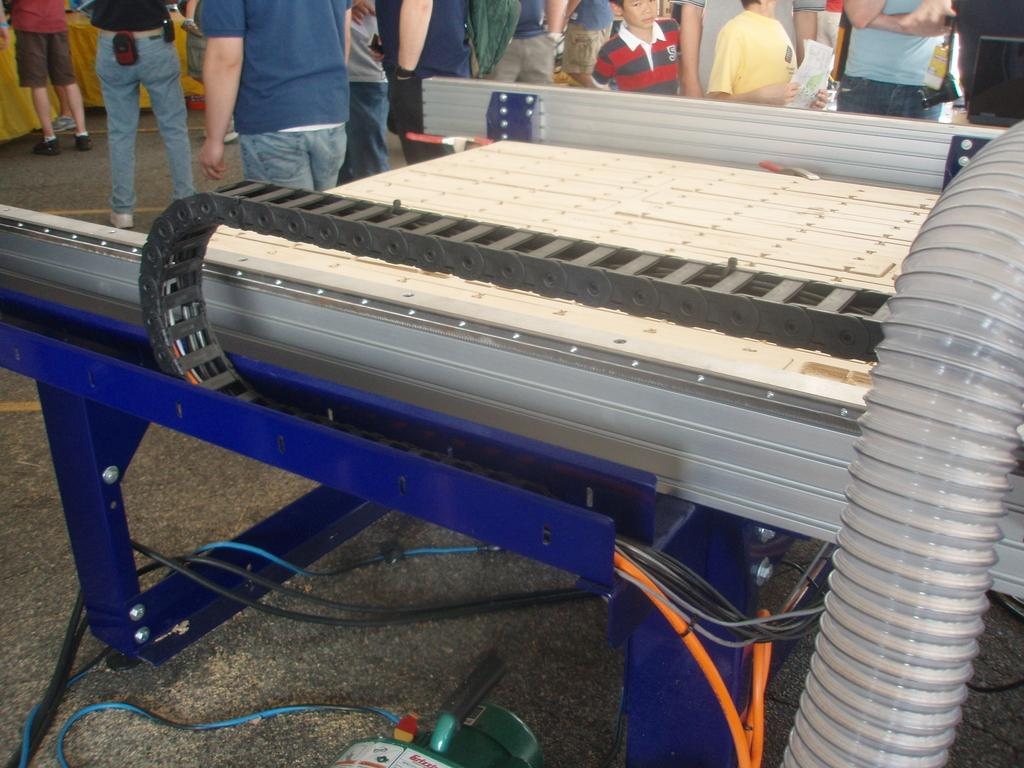What is the main object in the image? There is a machine in the image. What is connected to the machine? There are cables in the image. Are there any people present in the image? Yes, there are people near the machine. What type of toy can be seen rolling on the floor in the image? There is no toy present in the image, and no rolling object can be observed. 